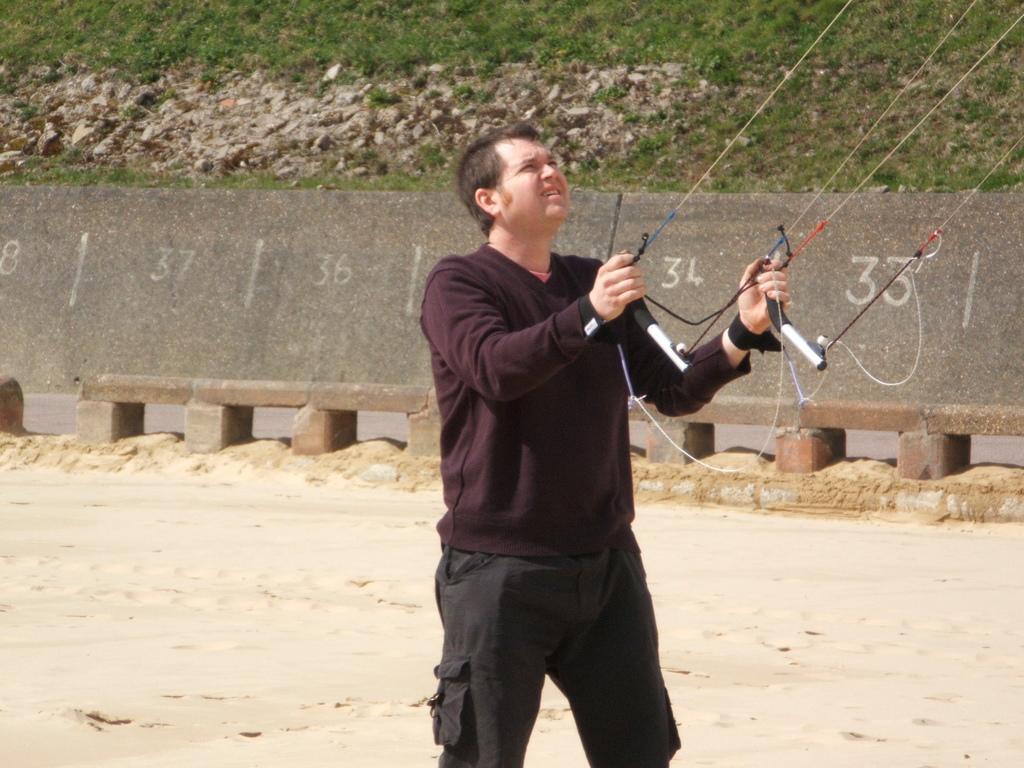How would you summarize this image in a sentence or two? In this image we can see a man standing on the surface holding the rods tied with the ropes. On the backside we can see a wall with some numbers on it, some stones and grass. 